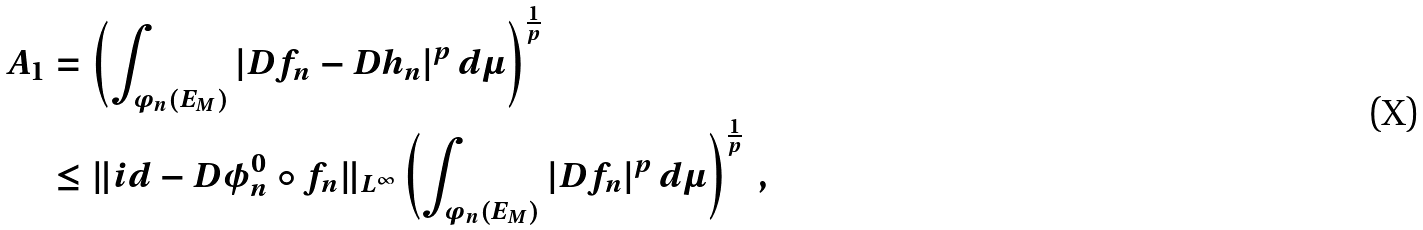<formula> <loc_0><loc_0><loc_500><loc_500>A _ { 1 } & = \left ( \int _ { \varphi _ { n } ( E _ { M } ) } | D f _ { n } - D h _ { n } | ^ { p } \, d \mu \right ) ^ { \frac { 1 } { p } } \\ & \leq \| i d - D \phi _ { n } ^ { 0 } \circ f _ { n } \| _ { L ^ { \infty } } \left ( \int _ { \varphi _ { n } ( E _ { M } ) } | D f _ { n } | ^ { p } \, d \mu \right ) ^ { \frac { 1 } { p } } \ ,</formula> 